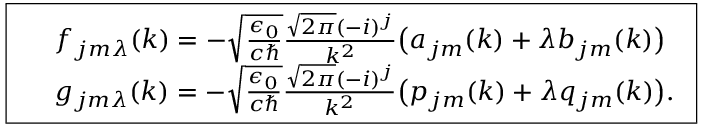<formula> <loc_0><loc_0><loc_500><loc_500>\boxed { \begin{array} { r l } & { f _ { j m \lambda } ( k ) = - \sqrt { \frac { \epsilon _ { 0 } } { c } } \frac { \sqrt { 2 \pi } ( - i ) ^ { j } } { k ^ { 2 } } \left ( a _ { j m } ( k ) + \lambda b _ { j m } ( k ) \right ) } \\ & { g _ { j m \lambda } ( k ) = - \sqrt { \frac { \epsilon _ { 0 } } { c } } \frac { \sqrt { 2 \pi } ( - i ) ^ { j } } { k ^ { 2 } } \left ( p _ { j m } ( k ) + \lambda q _ { j m } ( k ) \right ) . } \end{array} }</formula> 